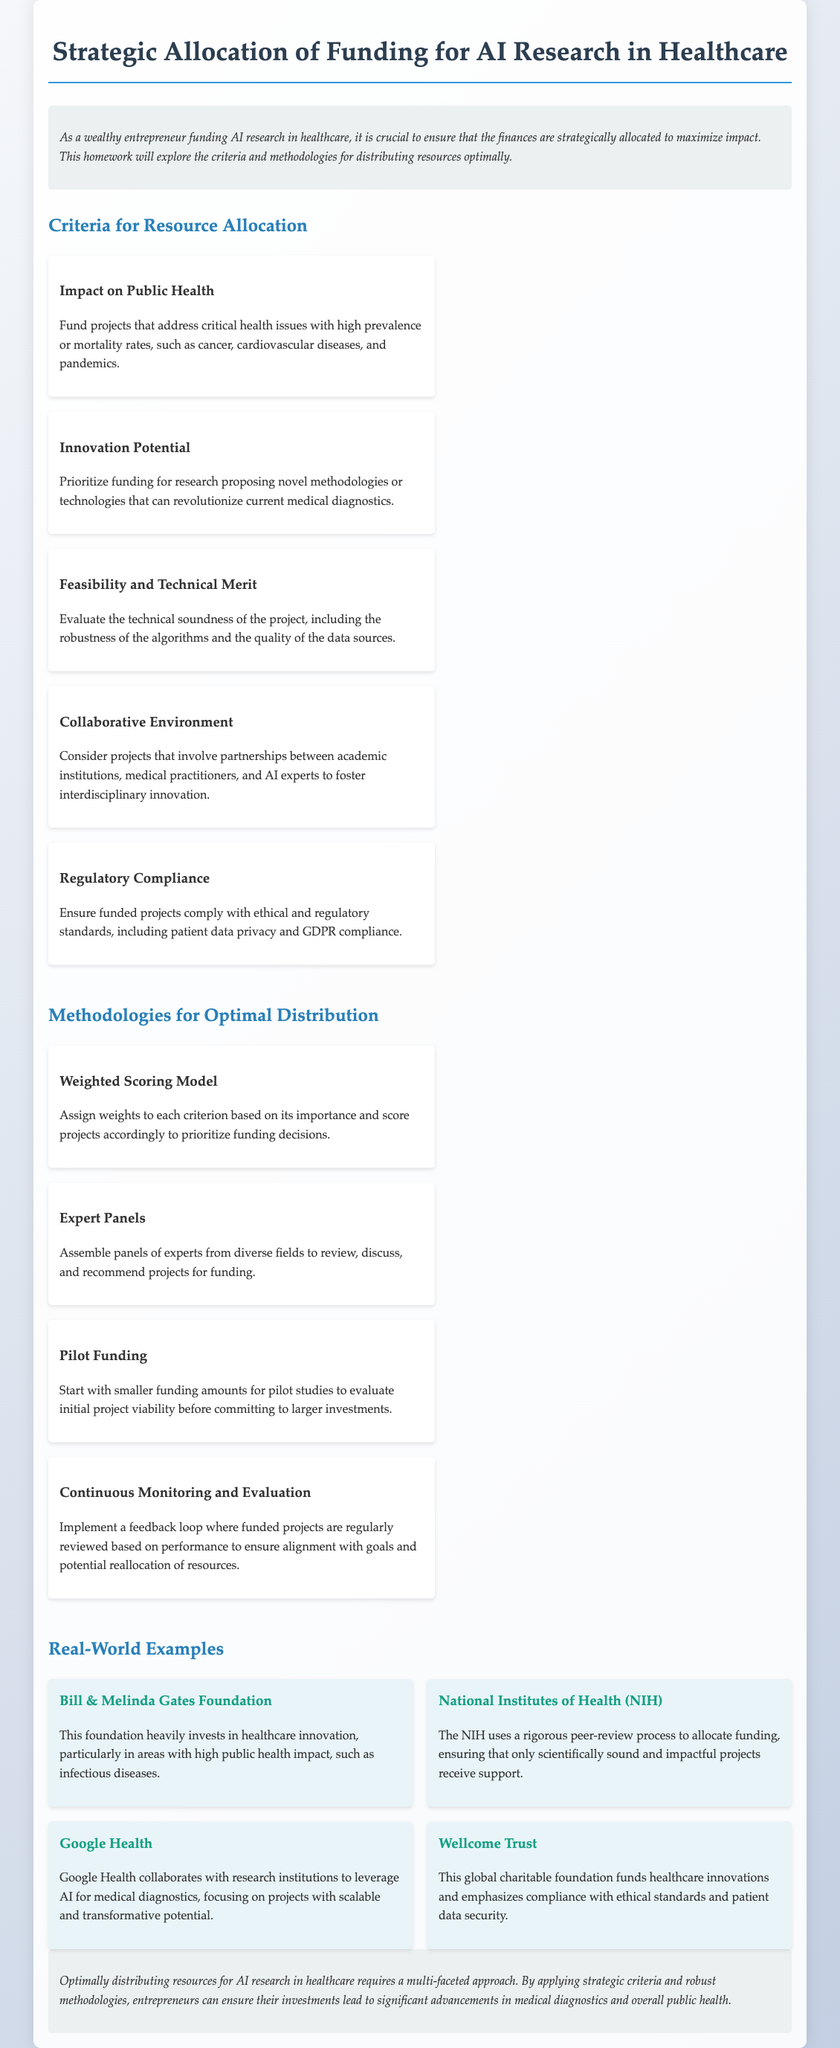What is the title of the document? The title of the document is found in the header, summarizing the main topic discussed.
Answer: Strategic Allocation of Funding for AI Research in Healthcare What is one of the criteria for resource allocation? The document lists several criteria for resource allocation; one can be found in the "Criteria for Resource Allocation" section.
Answer: Impact on Public Health Which methodology involves using expert panels? The document discusses various methodologies, one of which specifically mentions the involvement of experts.
Answer: Expert Panels How many criteria for resource allocation are listed in the document? The section titled "Criteria for Resource Allocation" contains a specific number of criteria.
Answer: Five What is the purpose of pilot funding according to the document? The term is defined in the context of evaluating project viability before larger investments are made, found in the "Methodologies for Optimal Distribution."
Answer: Evaluate initial project viability Name one organization mentioned in real-world examples. The section on real-world examples mentions several organizations that are relevant, with specific names provided.
Answer: Bill & Melinda Gates Foundation What common theme is emphasized in the conclusion? The conclusion summarizes the core idea of optimizing resources, which is reflected throughout the document.
Answer: Multi-faceted approach What color is primarily used for the heading text? The style section indicates the color for headings, specifically in the document's CSS.
Answer: Dark blue 